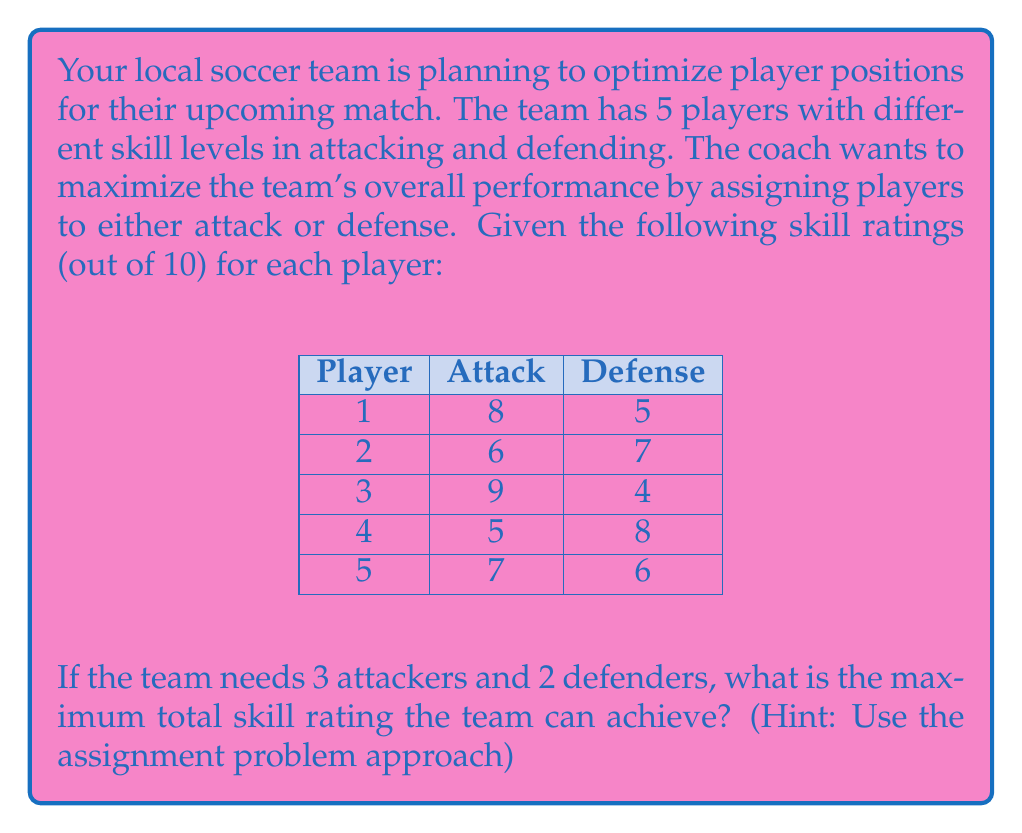What is the answer to this math problem? To solve this problem, we'll use the assignment problem approach from Operations Research. Here's a step-by-step solution:

1) First, we need to create a matrix of the "costs" (in this case, benefits) for each player in each position. We'll use negative values because we want to maximize the total skill rating.

   $$ \begin{matrix} 
   & \text{Attack} & \text{Defense} \\
   \text{Player 1} & -8 & -5 \\
   \text{Player 2} & -6 & -7 \\
   \text{Player 3} & -9 & -4 \\
   \text{Player 4} & -5 & -8 \\
   \text{Player 5} & -7 & -6
   \end{matrix} $$

2) We need to add dummy positions to balance the matrix (3 attack, 2 defense = 5 total, but we have 5 players and need 5 positions). We'll add 1 dummy attack position and 3 dummy defense positions with a cost of 0.

3) Now we have a balanced 5x5 matrix:

   $$ \begin{matrix} 
   & \text{A1} & \text{A2} & \text{A3} & \text{D1} & \text{D2} \\
   \text{P1} & -8 & -8 & -8 & -5 & -5 \\
   \text{P2} & -6 & -6 & -6 & -7 & -7 \\
   \text{P3} & -9 & -9 & -9 & -4 & -4 \\
   \text{P4} & -5 & -5 & -5 & -8 & -8 \\
   \text{P5} & -7 & -7 & -7 & -6 & -6
   \end{matrix} $$

4) We can solve this using the Hungarian algorithm. After applying the algorithm, we get the optimal assignment:
   - Player 1 to Attack
   - Player 2 to Defense
   - Player 3 to Attack
   - Player 4 to Defense
   - Player 5 to Attack

5) The total skill rating is therefore:
   $$ 8 + 7 + 9 + 8 + 7 = 39 $$

This assignment maximizes the total skill rating for the team.
Answer: 39 